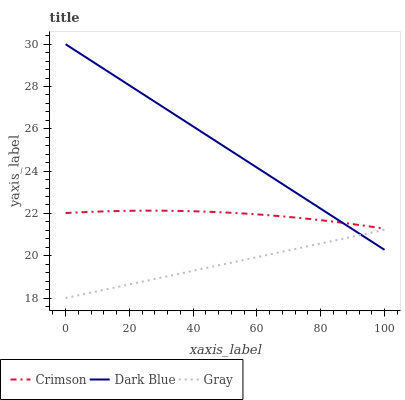Does Gray have the minimum area under the curve?
Answer yes or no. Yes. Does Dark Blue have the maximum area under the curve?
Answer yes or no. Yes. Does Dark Blue have the minimum area under the curve?
Answer yes or no. No. Does Gray have the maximum area under the curve?
Answer yes or no. No. Is Gray the smoothest?
Answer yes or no. Yes. Is Crimson the roughest?
Answer yes or no. Yes. Is Dark Blue the smoothest?
Answer yes or no. No. Is Dark Blue the roughest?
Answer yes or no. No. Does Gray have the lowest value?
Answer yes or no. Yes. Does Dark Blue have the lowest value?
Answer yes or no. No. Does Dark Blue have the highest value?
Answer yes or no. Yes. Does Gray have the highest value?
Answer yes or no. No. Is Gray less than Crimson?
Answer yes or no. Yes. Is Crimson greater than Gray?
Answer yes or no. Yes. Does Dark Blue intersect Gray?
Answer yes or no. Yes. Is Dark Blue less than Gray?
Answer yes or no. No. Is Dark Blue greater than Gray?
Answer yes or no. No. Does Gray intersect Crimson?
Answer yes or no. No. 